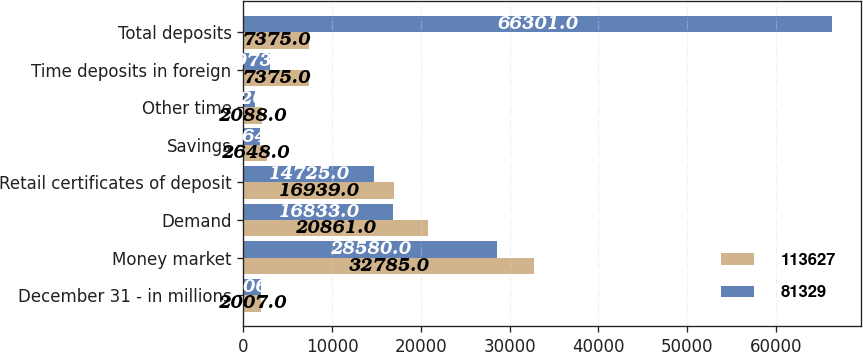Convert chart to OTSL. <chart><loc_0><loc_0><loc_500><loc_500><stacked_bar_chart><ecel><fcel>December 31 - in millions<fcel>Money market<fcel>Demand<fcel>Retail certificates of deposit<fcel>Savings<fcel>Other time<fcel>Time deposits in foreign<fcel>Total deposits<nl><fcel>113627<fcel>2007<fcel>32785<fcel>20861<fcel>16939<fcel>2648<fcel>2088<fcel>7375<fcel>7375<nl><fcel>81329<fcel>2006<fcel>28580<fcel>16833<fcel>14725<fcel>1864<fcel>1326<fcel>2973<fcel>66301<nl></chart> 